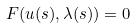Convert formula to latex. <formula><loc_0><loc_0><loc_500><loc_500>F ( u ( s ) , \lambda ( s ) ) = 0</formula> 